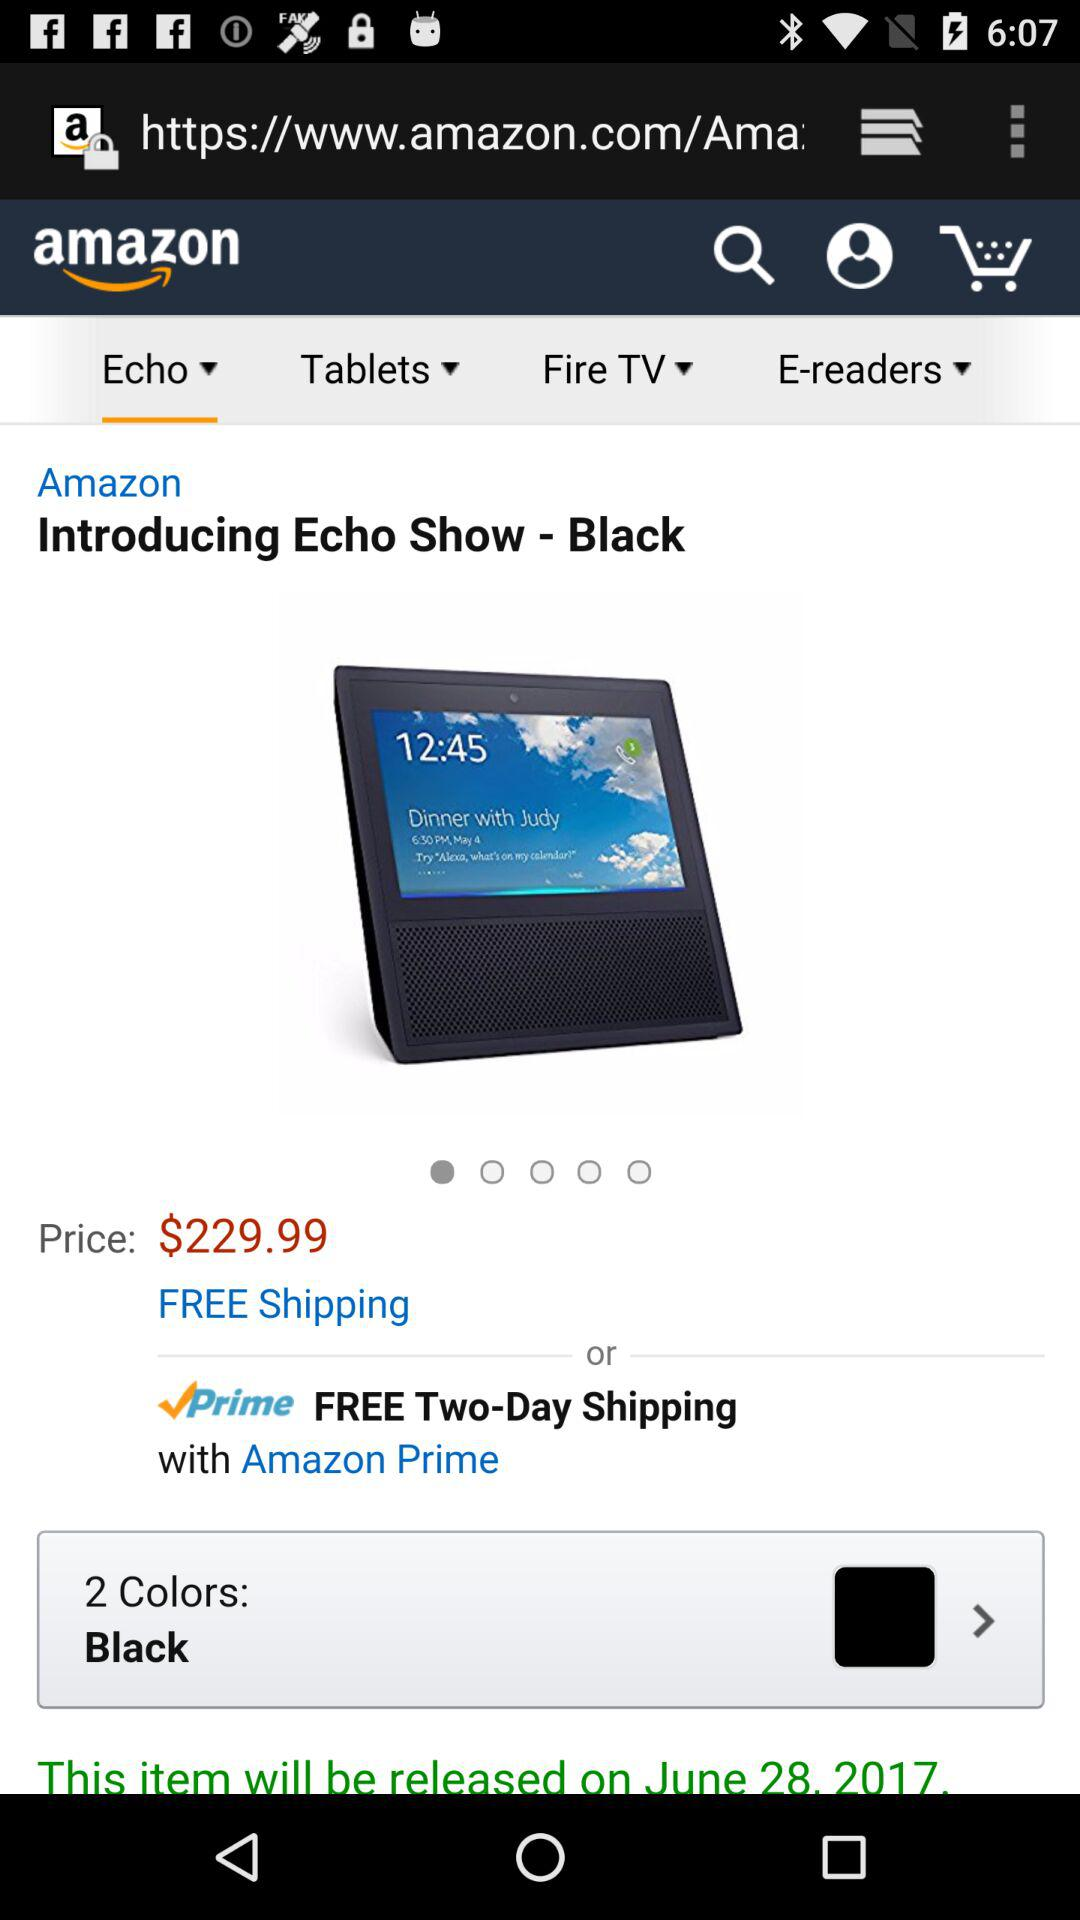What is the release date? The release date is June 28, 2017. 